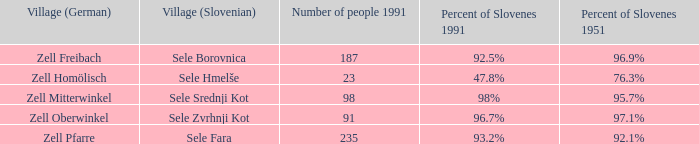3% slovene residents in 195 Zell Homölisch. 